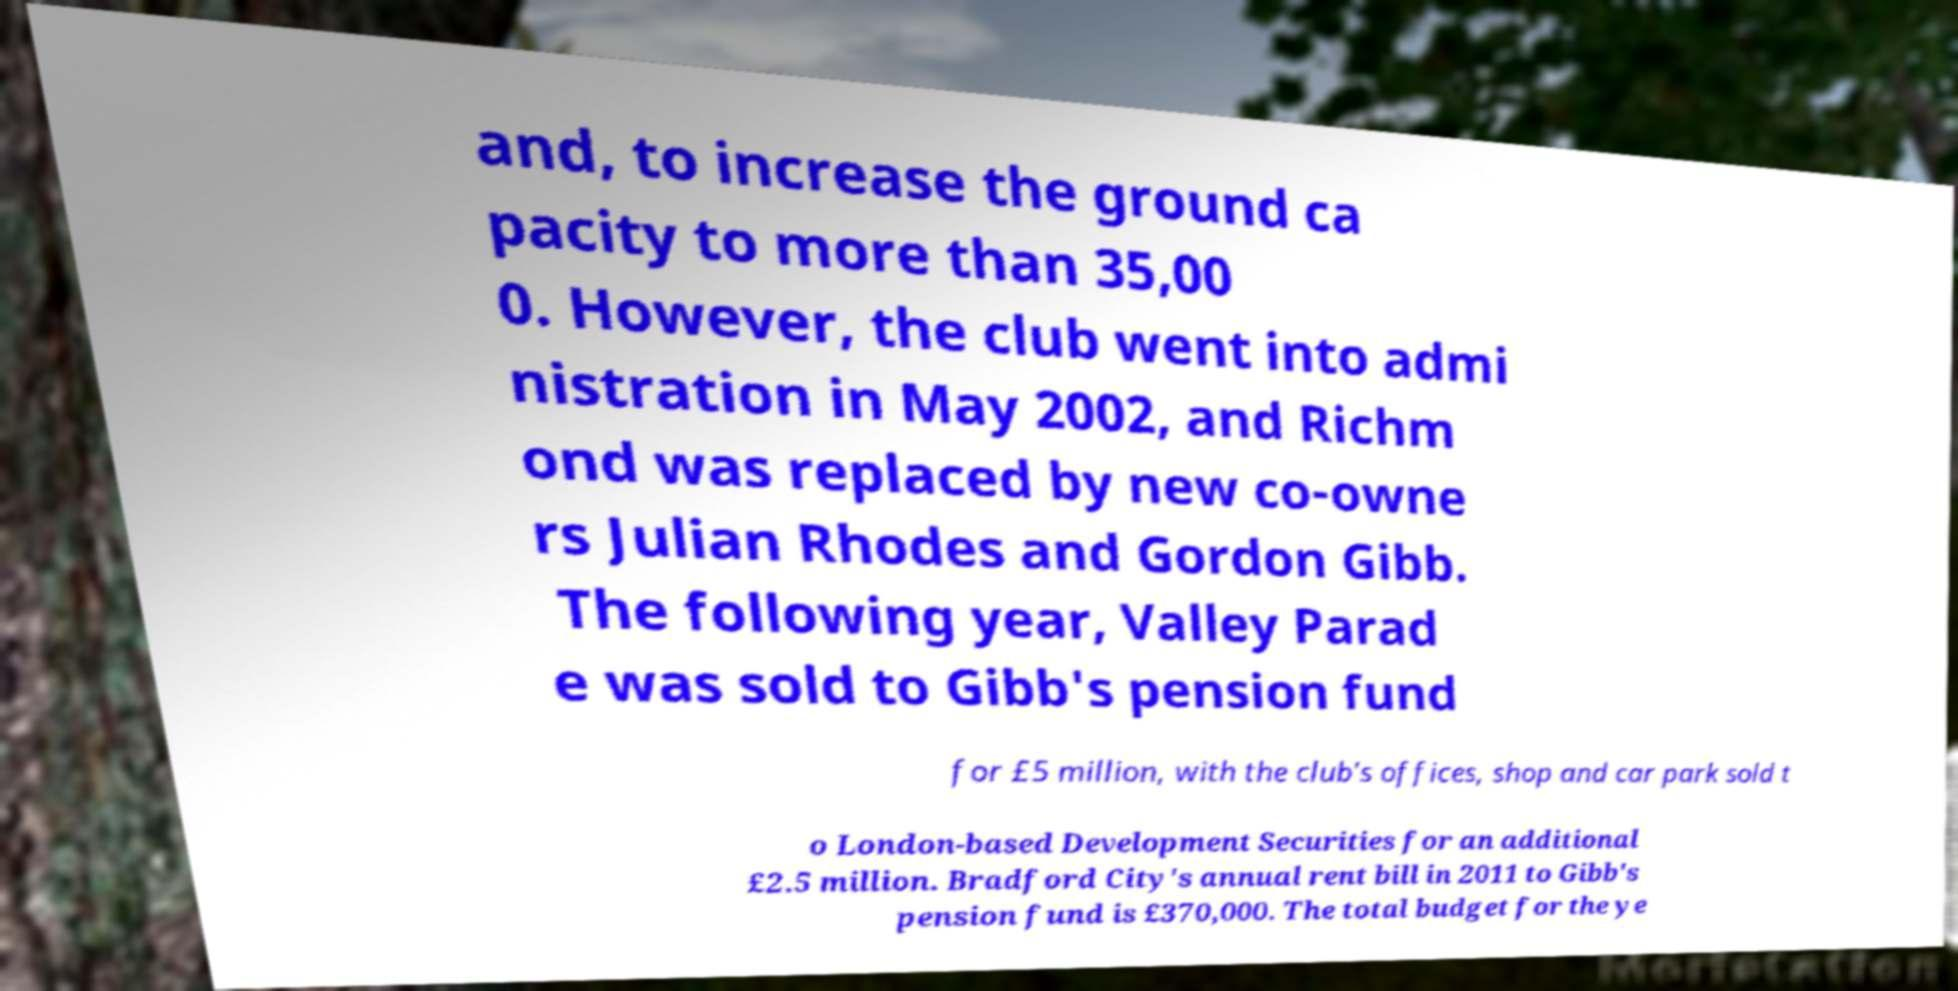What messages or text are displayed in this image? I need them in a readable, typed format. and, to increase the ground ca pacity to more than 35,00 0. However, the club went into admi nistration in May 2002, and Richm ond was replaced by new co-owne rs Julian Rhodes and Gordon Gibb. The following year, Valley Parad e was sold to Gibb's pension fund for £5 million, with the club's offices, shop and car park sold t o London-based Development Securities for an additional £2.5 million. Bradford City's annual rent bill in 2011 to Gibb's pension fund is £370,000. The total budget for the ye 